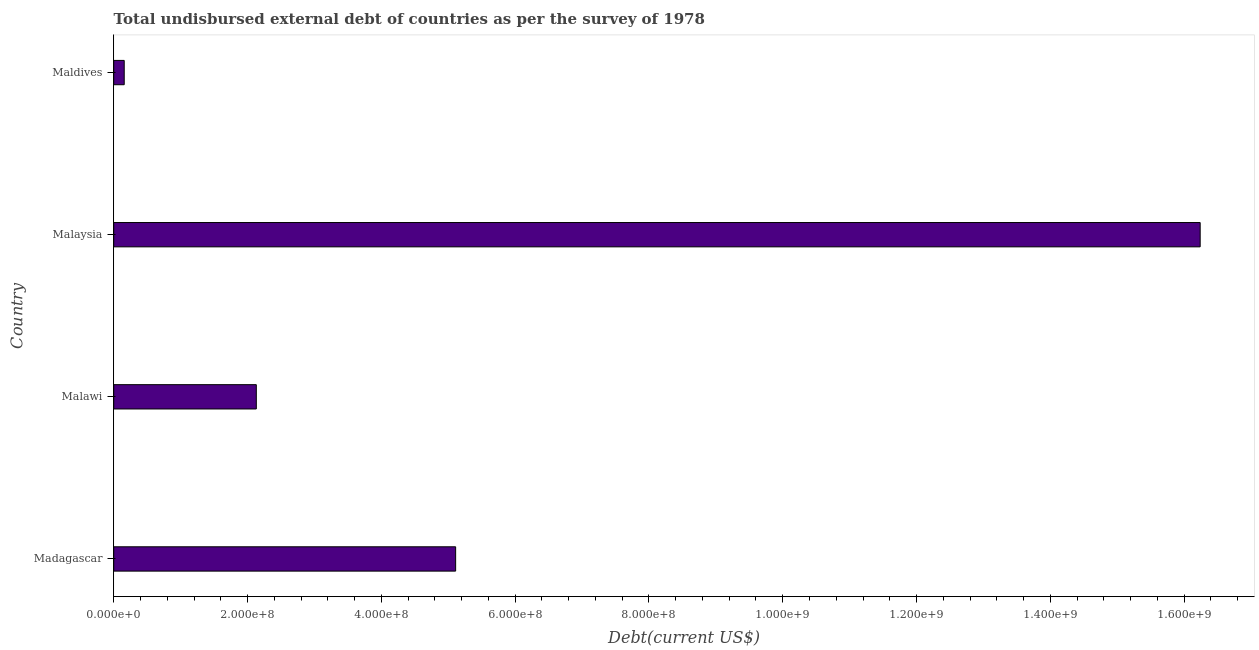Does the graph contain any zero values?
Ensure brevity in your answer.  No. What is the title of the graph?
Provide a short and direct response. Total undisbursed external debt of countries as per the survey of 1978. What is the label or title of the X-axis?
Ensure brevity in your answer.  Debt(current US$). What is the total debt in Malaysia?
Provide a short and direct response. 1.62e+09. Across all countries, what is the maximum total debt?
Keep it short and to the point. 1.62e+09. Across all countries, what is the minimum total debt?
Make the answer very short. 1.57e+07. In which country was the total debt maximum?
Ensure brevity in your answer.  Malaysia. In which country was the total debt minimum?
Keep it short and to the point. Maldives. What is the sum of the total debt?
Ensure brevity in your answer.  2.36e+09. What is the difference between the total debt in Malaysia and Maldives?
Keep it short and to the point. 1.61e+09. What is the average total debt per country?
Keep it short and to the point. 5.91e+08. What is the median total debt?
Offer a very short reply. 3.62e+08. What is the ratio of the total debt in Malaysia to that in Maldives?
Offer a very short reply. 103.64. Is the total debt in Malawi less than that in Maldives?
Your response must be concise. No. Is the difference between the total debt in Madagascar and Maldives greater than the difference between any two countries?
Provide a short and direct response. No. What is the difference between the highest and the second highest total debt?
Provide a short and direct response. 1.11e+09. Is the sum of the total debt in Madagascar and Malawi greater than the maximum total debt across all countries?
Your response must be concise. No. What is the difference between the highest and the lowest total debt?
Your answer should be very brief. 1.61e+09. Are all the bars in the graph horizontal?
Give a very brief answer. Yes. What is the difference between two consecutive major ticks on the X-axis?
Keep it short and to the point. 2.00e+08. What is the Debt(current US$) in Madagascar?
Provide a short and direct response. 5.11e+08. What is the Debt(current US$) in Malawi?
Give a very brief answer. 2.13e+08. What is the Debt(current US$) in Malaysia?
Ensure brevity in your answer.  1.62e+09. What is the Debt(current US$) of Maldives?
Give a very brief answer. 1.57e+07. What is the difference between the Debt(current US$) in Madagascar and Malawi?
Offer a very short reply. 2.98e+08. What is the difference between the Debt(current US$) in Madagascar and Malaysia?
Provide a short and direct response. -1.11e+09. What is the difference between the Debt(current US$) in Madagascar and Maldives?
Your answer should be compact. 4.95e+08. What is the difference between the Debt(current US$) in Malawi and Malaysia?
Ensure brevity in your answer.  -1.41e+09. What is the difference between the Debt(current US$) in Malawi and Maldives?
Offer a terse response. 1.97e+08. What is the difference between the Debt(current US$) in Malaysia and Maldives?
Your answer should be very brief. 1.61e+09. What is the ratio of the Debt(current US$) in Madagascar to that in Malawi?
Keep it short and to the point. 2.4. What is the ratio of the Debt(current US$) in Madagascar to that in Malaysia?
Your answer should be compact. 0.32. What is the ratio of the Debt(current US$) in Madagascar to that in Maldives?
Ensure brevity in your answer.  32.62. What is the ratio of the Debt(current US$) in Malawi to that in Malaysia?
Offer a terse response. 0.13. What is the ratio of the Debt(current US$) in Malawi to that in Maldives?
Your response must be concise. 13.6. What is the ratio of the Debt(current US$) in Malaysia to that in Maldives?
Your response must be concise. 103.64. 